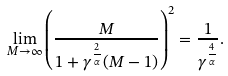<formula> <loc_0><loc_0><loc_500><loc_500>\lim _ { M \rightarrow \infty } \left ( \frac { M } { 1 + \gamma ^ { \frac { 2 } { \alpha } } ( M - 1 ) } \right ) ^ { 2 } = \frac { 1 } { \gamma ^ { \frac { 4 } { \alpha } } } .</formula> 